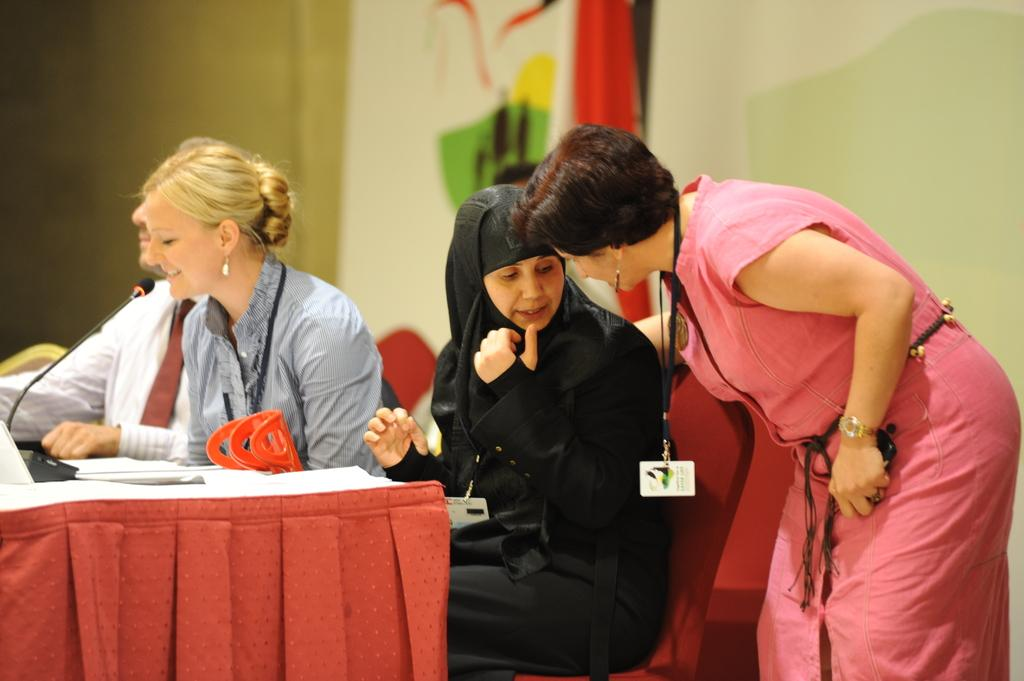What are the people in the image doing? The people in the image are sitting in chairs in front of a table. What is the woman in the image doing? The woman is standing. What can be seen in the background of the image? In the background, there is a cloth and a wall. How many cattle are present in the image? There are no cattle present in the image. What type of canvas is being used to create the image? The image is not a painting or artwork, so there is no canvas involved in its creation. 